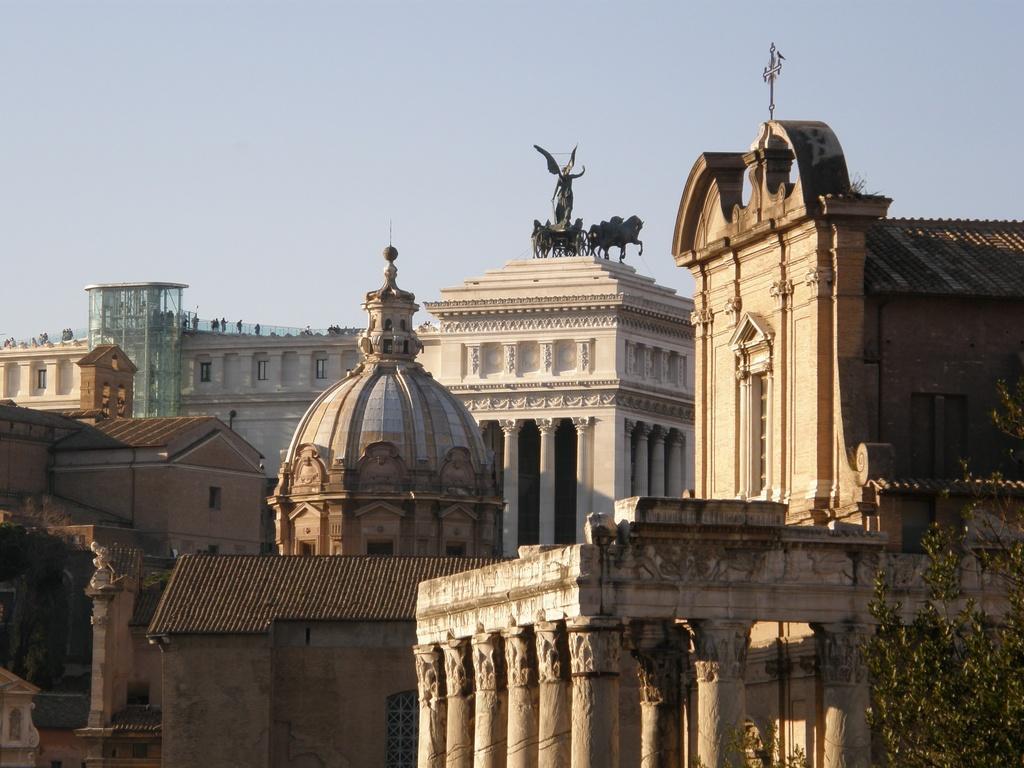Describe this image in one or two sentences. In this image ta the bottom there are some buildings and some statues, on the top of the image there is sky and on the right side there are some trees. 